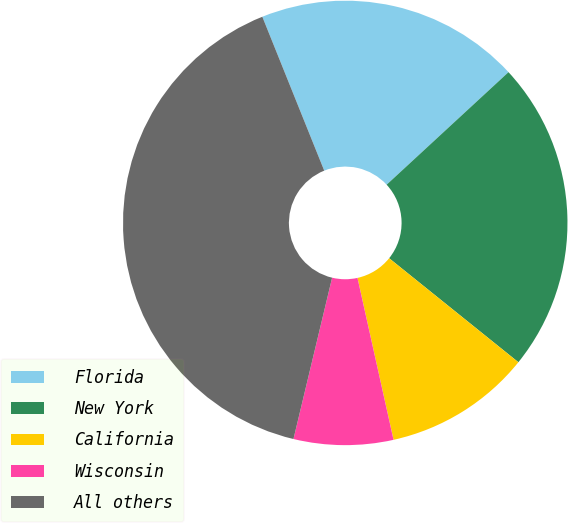Convert chart. <chart><loc_0><loc_0><loc_500><loc_500><pie_chart><fcel>Florida<fcel>New York<fcel>California<fcel>Wisconsin<fcel>All others<nl><fcel>19.22%<fcel>22.65%<fcel>10.73%<fcel>7.23%<fcel>40.17%<nl></chart> 